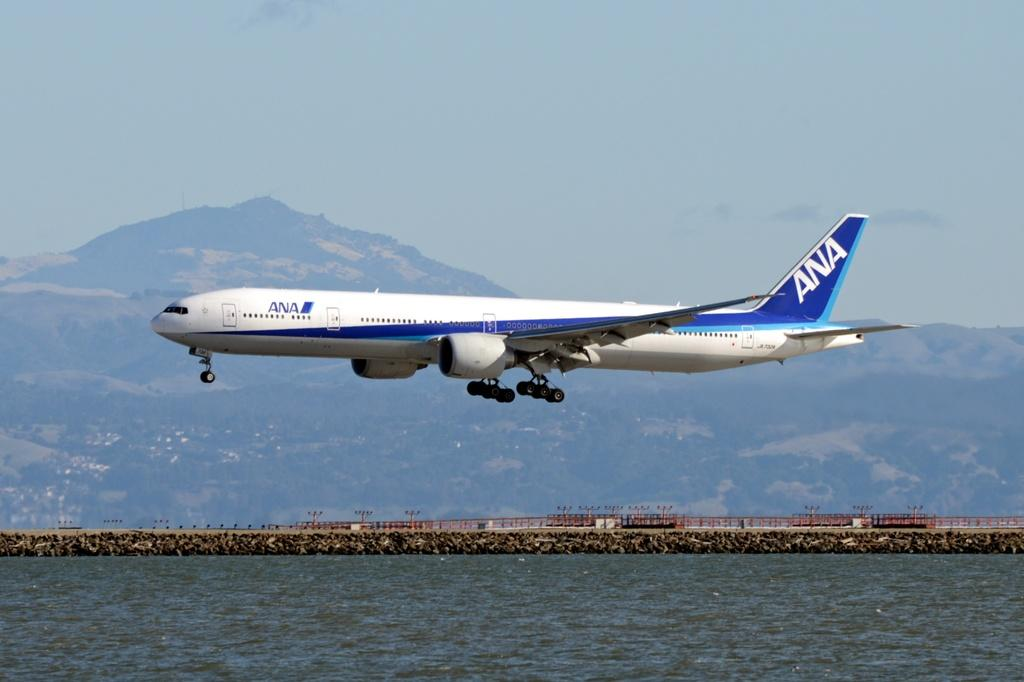<image>
Present a compact description of the photo's key features. An ANA jet is flying nearly parallel to the water underneath it. 